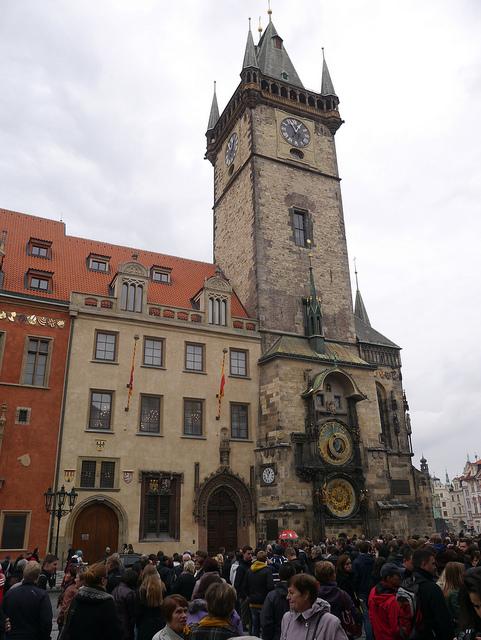Are all the buildings the same color?
Concise answer only. No. How many people are visible?
Keep it brief. 200. Are the people fighting?
Be succinct. No. How many windows can be seen?
Write a very short answer. 17. What event has likely just taken place?
Quick response, please. Parade. How many redheads do you see?
Keep it brief. 0. How many clocks are on the building?
Answer briefly. 3. 